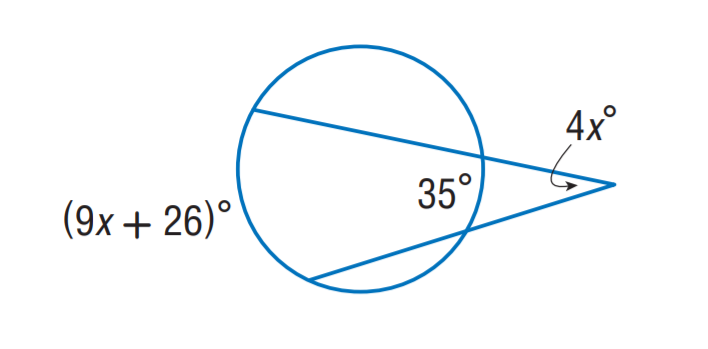Answer the mathemtical geometry problem and directly provide the correct option letter.
Question: Find x.
Choices: A: 9 B: 17.5 C: 26 D: 36 A 